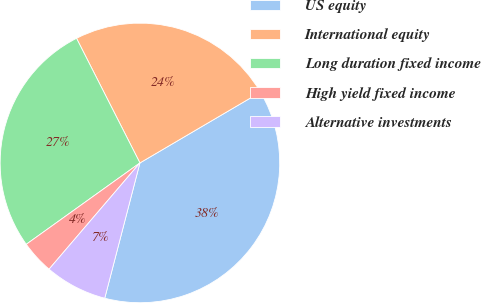<chart> <loc_0><loc_0><loc_500><loc_500><pie_chart><fcel>US equity<fcel>International equity<fcel>Long duration fixed income<fcel>High yield fixed income<fcel>Alternative investments<nl><fcel>37.5%<fcel>24.04%<fcel>27.4%<fcel>3.85%<fcel>7.21%<nl></chart> 